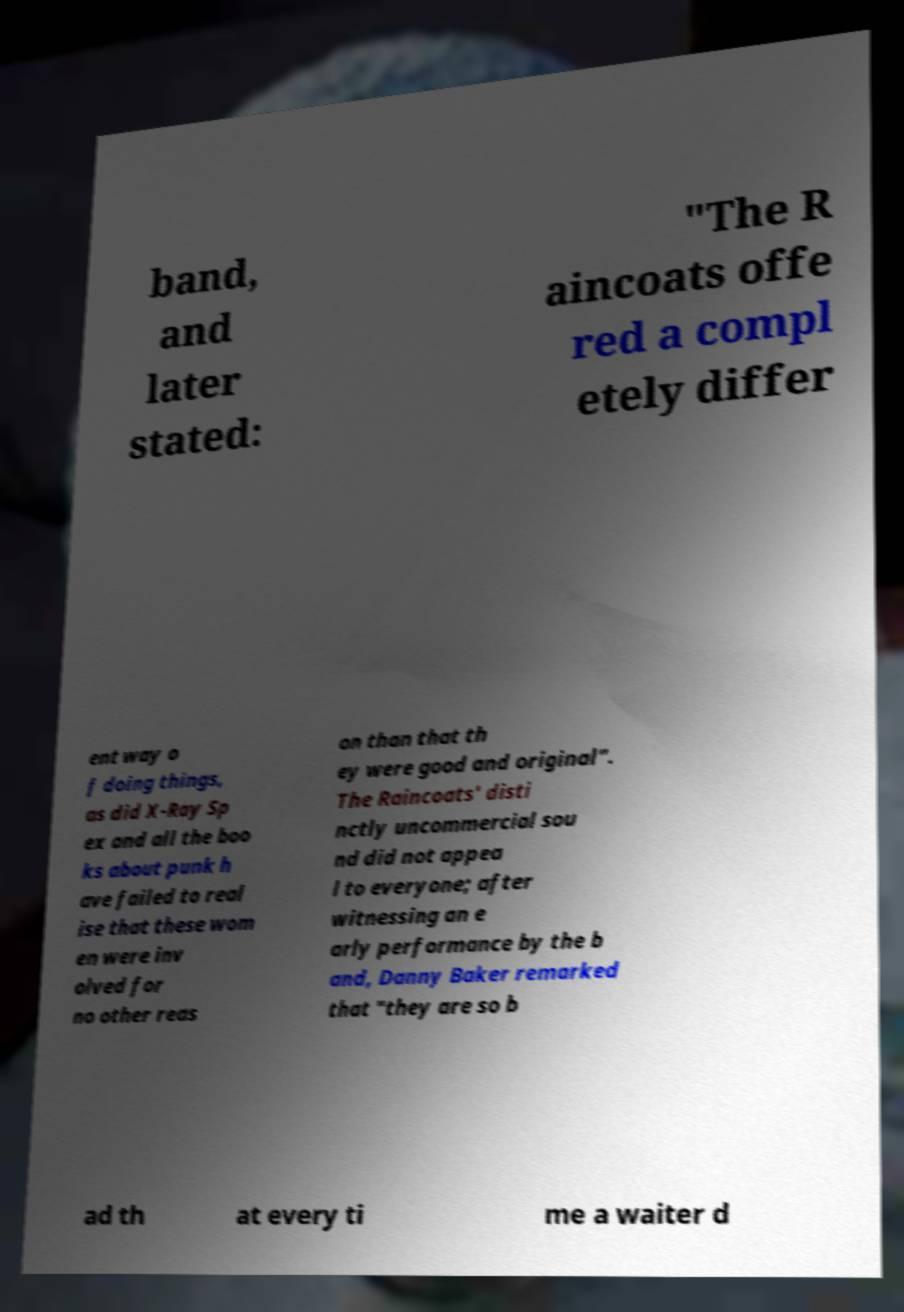There's text embedded in this image that I need extracted. Can you transcribe it verbatim? band, and later stated: "The R aincoats offe red a compl etely differ ent way o f doing things, as did X-Ray Sp ex and all the boo ks about punk h ave failed to real ise that these wom en were inv olved for no other reas on than that th ey were good and original". The Raincoats' disti nctly uncommercial sou nd did not appea l to everyone; after witnessing an e arly performance by the b and, Danny Baker remarked that "they are so b ad th at every ti me a waiter d 